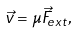Convert formula to latex. <formula><loc_0><loc_0><loc_500><loc_500>\vec { v } = \mu \vec { F } _ { e x t } ,</formula> 